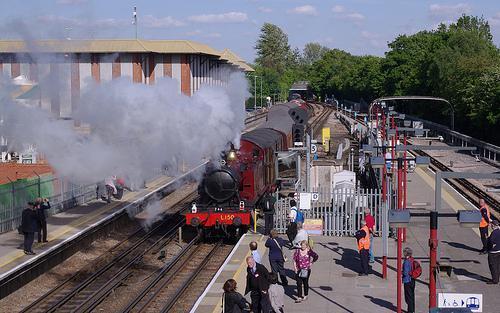How many people on the train platform have orange vests?
Give a very brief answer. 2. 